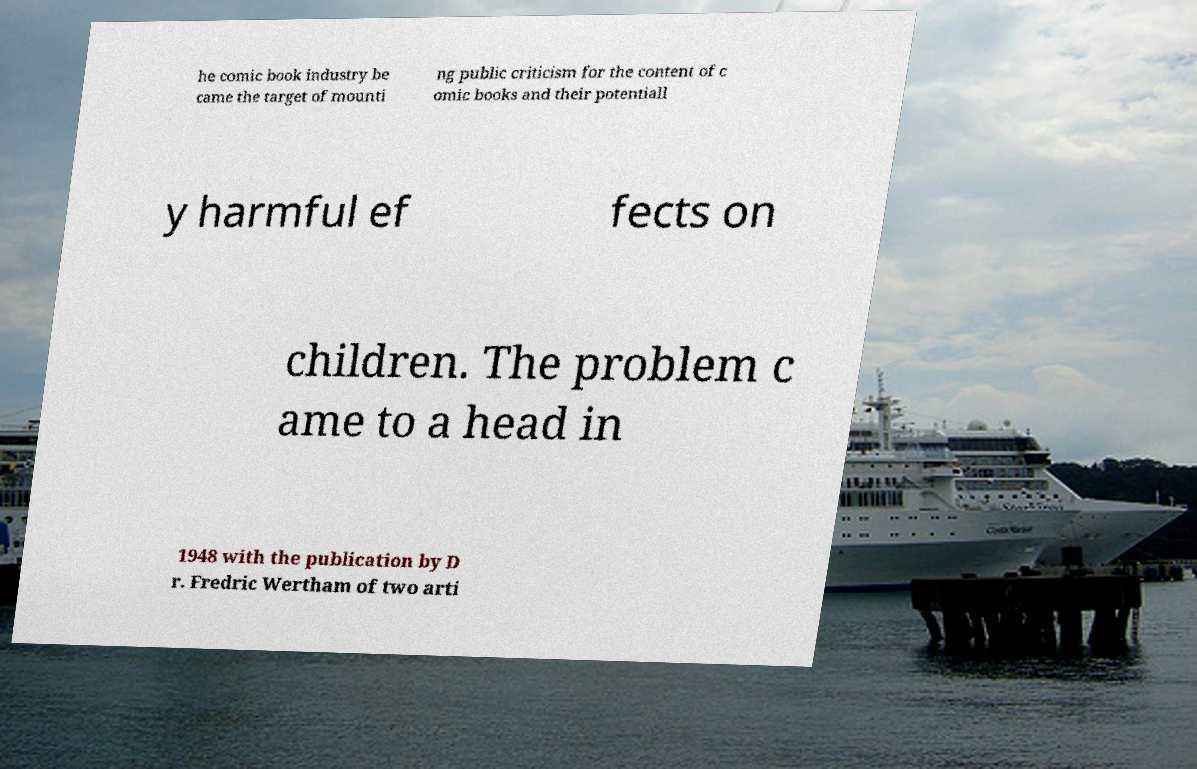What messages or text are displayed in this image? I need them in a readable, typed format. he comic book industry be came the target of mounti ng public criticism for the content of c omic books and their potentiall y harmful ef fects on children. The problem c ame to a head in 1948 with the publication by D r. Fredric Wertham of two arti 